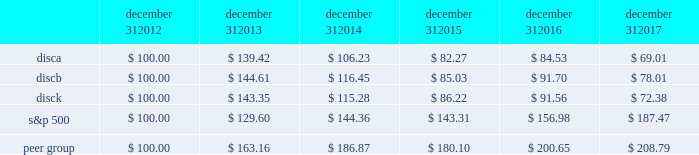Part ii item 5 .
Market for registrant 2019s common equity , related stockholder matters and issuer purchases of equity securities .
Our series a common stock , series b common stock and series c common stock are listed and traded on the nasdaq global select market ( 201cnasdaq 201d ) under the symbols 201cdisca , 201d 201cdiscb 201d and 201cdisck , 201d respectively .
The table sets forth , for the periods indicated , the range of high and low sales prices per share of our series a common stock , series b common stock and series c common stock as reported on yahoo! finance ( finance.yahoo.com ) .
Series a common stock series b common stock series c common stock high low high low high low fourth quarter $ 23.73 $ 16.28 $ 26.80 $ 20.00 $ 22.47 $ 15.27 third quarter $ 27.18 $ 20.80 $ 27.90 $ 22.00 $ 26.21 $ 19.62 second quarter $ 29.40 $ 25.11 $ 29.55 $ 25.45 $ 28.90 $ 24.39 first quarter $ 29.62 $ 26.34 $ 29.65 $ 27.55 $ 28.87 $ 25.76 fourth quarter $ 29.55 $ 25.01 $ 30.50 $ 26.00 $ 28.66 $ 24.20 third quarter $ 26.97 $ 24.27 $ 28.00 $ 25.21 $ 26.31 $ 23.44 second quarter $ 29.31 $ 23.73 $ 29.34 $ 24.15 $ 28.48 $ 22.54 first quarter $ 29.42 $ 24.33 $ 29.34 $ 24.30 $ 28.00 $ 23.81 as of february 21 , 2018 , there were approximately 1308 , 75 and 1414 record holders of our series a common stock , series b common stock and series c common stock , respectively .
These amounts do not include the number of shareholders whose shares are held of record by banks , brokerage houses or other institutions , but include each such institution as one shareholder .
We have not paid any cash dividends on our series a common stock , series b common stock or series c common stock , and we have no present intention to do so .
Payment of cash dividends , if any , will be determined by our board of directors after consideration of our earnings , financial condition and other relevant factors such as our credit facility's restrictions on our ability to declare dividends in certain situations .
Purchases of equity securities the table presents information about our repurchases of common stock that were made through open market transactions during the three months ended december 31 , 2017 ( in millions , except per share amounts ) .
Period total number of series c shares purchased average paid per share : series c ( a ) total number of shares purchased as part of publicly announced plans or programs ( b ) ( c ) approximate dollar value of shares that may yet be purchased under the plans or programs ( a ) ( b ) october 1 , 2017 - october 31 , 2017 2014 $ 2014 2014 $ 2014 november 1 , 2017 - november 30 , 2017 2014 $ 2014 2014 $ 2014 december 1 , 2017 - december 31 , 2017 2014 $ 2014 2014 $ 2014 total 2014 2014 $ 2014 ( a ) the amounts do not give effect to any fees , commissions or other costs associated with repurchases of shares .
( b ) under the stock repurchase program , management was authorized to purchase shares of the company's common stock from time to time through open market purchases or privately negotiated transactions at prevailing prices or pursuant to one or more accelerated stock repurchase agreements or other derivative arrangements as permitted by securities laws and other legal requirements , and subject to stock price , business and market conditions and other factors .
The company's authorization under the program expired on october 8 , 2017 and we have not repurchased any shares of common stock since then .
We historically have funded and in the future may fund stock repurchases through a combination of cash on hand and cash generated by operations and the issuance of debt .
In the future , if further authorization is provided , we may also choose to fund stock repurchases through borrowings under our revolving credit facility or future financing transactions .
There were no repurchases of our series a and b common stock during 2017 and no repurchases of series c common stock during the three months ended december 31 , 2017 .
The company first announced its stock repurchase program on august 3 , 2010 .
( c ) we entered into an agreement with advance/newhouse to repurchase , on a quarterly basis , a number of shares of series c-1 convertible preferred stock convertible into a number of shares of series c common stock .
We did not convert any any shares of series c-1 convertible preferred stock during the three months ended december 31 , 2017 .
There are no planned repurchases of series c-1 convertible preferred stock for the first quarter of 2018 as there were no repurchases of series a or series c common stock during the three months ended december 31 , 2017 .
Stock performance graph the following graph sets forth the cumulative total shareholder return on our series a common stock , series b common stock and series c common stock as compared with the cumulative total return of the companies listed in the standard and poor 2019s 500 stock index ( 201cs&p 500 index 201d ) and a peer group of companies comprised of cbs corporation class b common stock , scripps network interactive , inc. , time warner , inc. , twenty-first century fox , inc .
Class a common stock ( news corporation class a common stock prior to june 2013 ) , viacom , inc .
Class b common stock and the walt disney company .
The graph assumes $ 100 originally invested on december 31 , 2012 in each of our series a common stock , series b common stock and series c common stock , the s&p 500 index , and the stock of our peer group companies , including reinvestment of dividends , for the years ended december 31 , 2013 , 2014 , 2015 , 2016 and 2017 .
December 31 , december 31 , december 31 , december 31 , december 31 , december 31 .

Did the 5 year c series return outperform the s&p 500? 
Computations: (72.38 > 187.47)
Answer: no. 